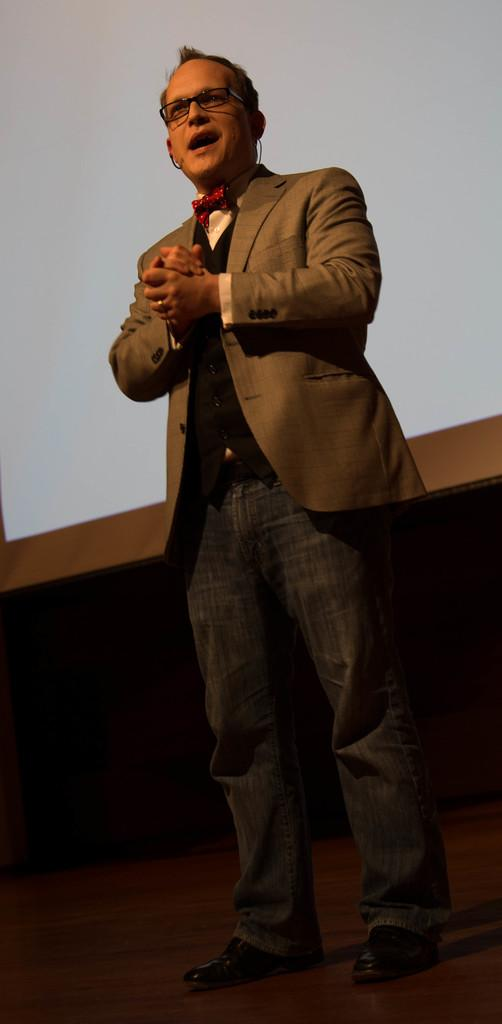What is the man in the image doing? The man is standing and speaking in the image. What can be seen in the background of the image? There are objects in the background of the image. What colors are the objects in the background? The objects in the background have white, brown, and black colors. Reasoning: Let' Let's think step by step in order to produce the conversation. We start by identifying the main subject in the image, which is the man standing and speaking. Then, we expand the conversation to include the background of the image, focusing on the objects and their colors. Each question is designed to elicit a specific detail about the image that is known from the provided facts. Absurd Question/Answer: What is the profit margin of the engine in the image? There is no engine present in the image, so it's not possible to determine the profit margin. How many chairs are visible in the image? There is no mention of chairs in the provided facts, so we cannot determine the number of chairs in the image. What is the profit margin of the engine in the image? There is no engine present in the image, so it's not possible to determine the profit margin. How many chairs are visible in the image? There is no mention of chairs in the provided facts, so we cannot determine the number of chairs in the image. 